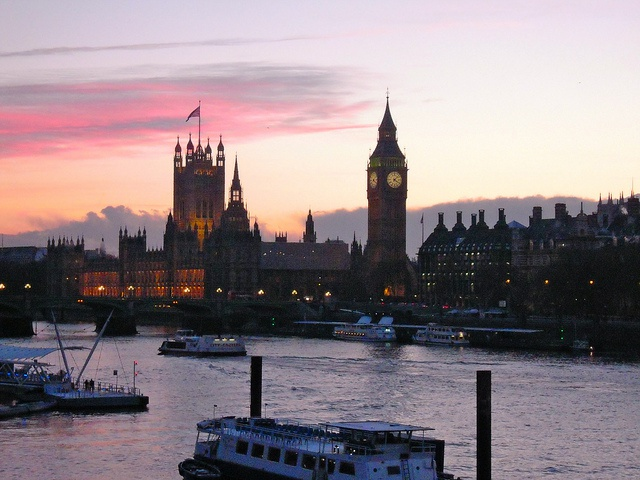Describe the objects in this image and their specific colors. I can see boat in darkgray, black, navy, darkblue, and gray tones, boat in darkgray, black, navy, gray, and darkblue tones, boat in darkgray, black, navy, darkblue, and gray tones, boat in darkgray, black, gray, and darkblue tones, and boat in darkgray, black, navy, gray, and darkblue tones in this image. 